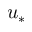Convert formula to latex. <formula><loc_0><loc_0><loc_500><loc_500>u _ { * }</formula> 